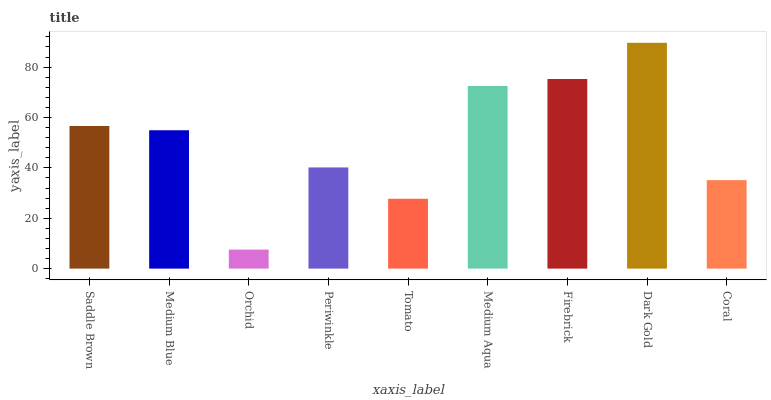Is Medium Blue the minimum?
Answer yes or no. No. Is Medium Blue the maximum?
Answer yes or no. No. Is Saddle Brown greater than Medium Blue?
Answer yes or no. Yes. Is Medium Blue less than Saddle Brown?
Answer yes or no. Yes. Is Medium Blue greater than Saddle Brown?
Answer yes or no. No. Is Saddle Brown less than Medium Blue?
Answer yes or no. No. Is Medium Blue the high median?
Answer yes or no. Yes. Is Medium Blue the low median?
Answer yes or no. Yes. Is Saddle Brown the high median?
Answer yes or no. No. Is Firebrick the low median?
Answer yes or no. No. 